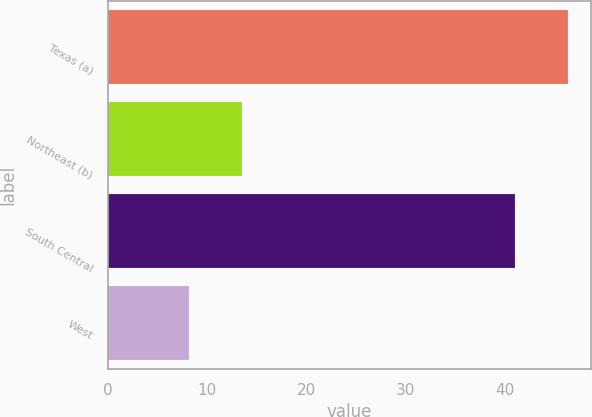Convert chart to OTSL. <chart><loc_0><loc_0><loc_500><loc_500><bar_chart><fcel>Texas (a)<fcel>Northeast (b)<fcel>South Central<fcel>West<nl><fcel>46.4<fcel>13.5<fcel>41.1<fcel>8.2<nl></chart> 